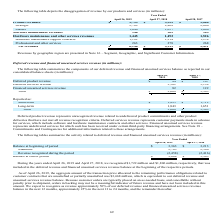From Netapp's financial document, Which years does the company provide information for components of the company's deferred revenue and financed unearned services balance? The document shows two values: 2019 and 2018. From the document: "April 26, 2019 April 27, 2018 April 28, 2017 April 26, 2019 April 27, 2018 April 28, 2017..." Also, What does deferred product revenue represent? unrecognized revenue related to undelivered product commitments and other product deliveries that have not met all revenue recognition criteria. The document states: "Deferred product revenue represents unrecognized revenue related to undelivered product commitments and other product deliveries that have not met all..." Also, What was the financed unearned services revenue in 2019? According to the financial document, 82 (in millions). The relevant text states: "Financed unearned services revenue 82 122..." Also, How many years did financed unearned services revenue exceed $100 million? Based on the analysis, there are 1 instances. The counting process: 2018. Also, can you calculate: What was the change in deferred services revenue between 2018 and 2019? Based on the calculation: 3,502-3,134, the result is 368 (in millions). This is based on the information: "Deferred services revenue 3,502 3,134 Deferred services revenue 3,502 3,134..." The key data points involved are: 3,134, 3,502. Also, can you calculate: What was the percentage change in revenues reported as long-term between 2018 and 2019? To answer this question, I need to perform calculations using the financial data. The calculation is: (1,843-1,651)/1,651, which equals 11.63 (percentage). This is based on the information: "Long-term 1,843 1,651 Long-term 1,843 1,651..." The key data points involved are: 1,651, 1,843. 